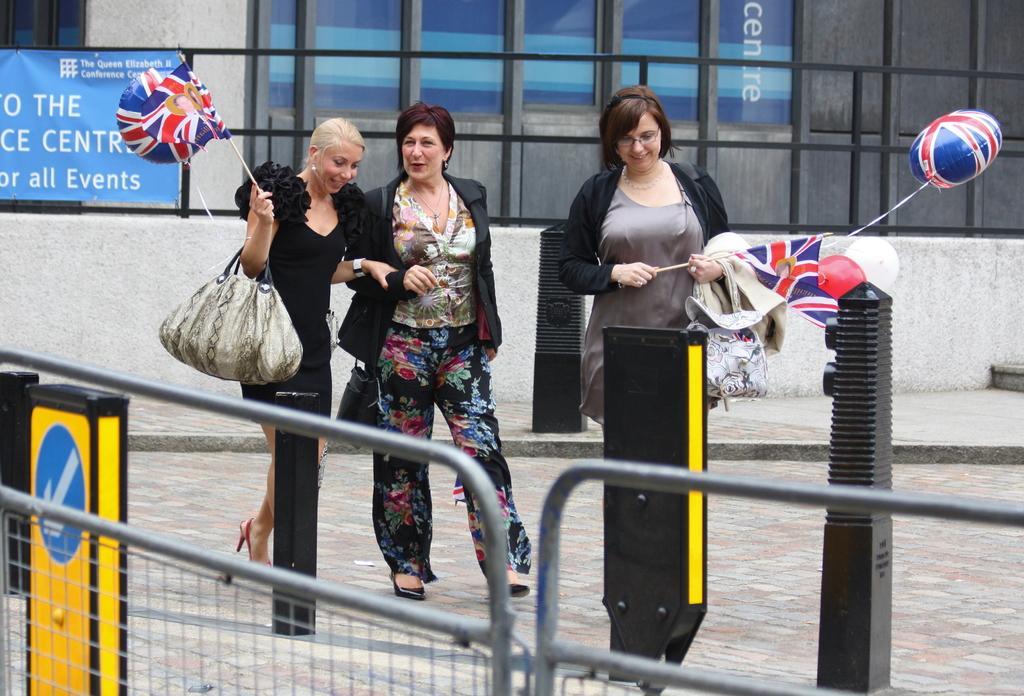In one or two sentences, can you explain what this image depicts? In the image there are three woman stood and smiling. The left side woman with black dress has a flag in her right hand with a handbag. It seems to be on road. The background there is a building with many glass windows and in the front there is a railing. 